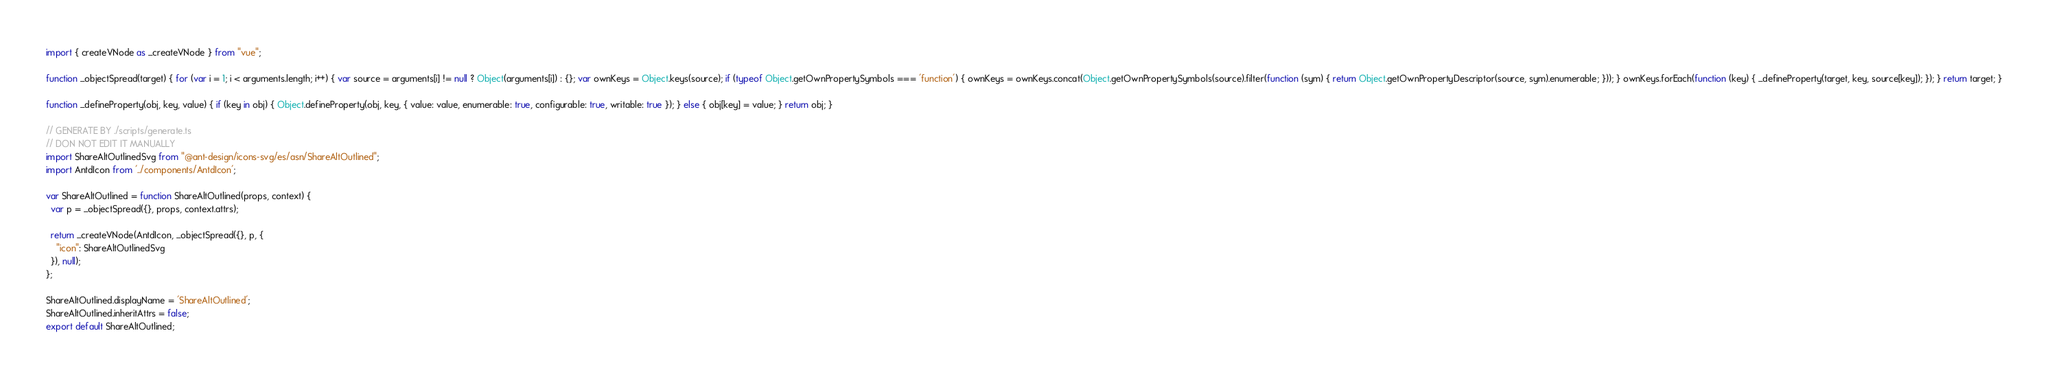Convert code to text. <code><loc_0><loc_0><loc_500><loc_500><_JavaScript_>import { createVNode as _createVNode } from "vue";

function _objectSpread(target) { for (var i = 1; i < arguments.length; i++) { var source = arguments[i] != null ? Object(arguments[i]) : {}; var ownKeys = Object.keys(source); if (typeof Object.getOwnPropertySymbols === 'function') { ownKeys = ownKeys.concat(Object.getOwnPropertySymbols(source).filter(function (sym) { return Object.getOwnPropertyDescriptor(source, sym).enumerable; })); } ownKeys.forEach(function (key) { _defineProperty(target, key, source[key]); }); } return target; }

function _defineProperty(obj, key, value) { if (key in obj) { Object.defineProperty(obj, key, { value: value, enumerable: true, configurable: true, writable: true }); } else { obj[key] = value; } return obj; }

// GENERATE BY ./scripts/generate.ts
// DON NOT EDIT IT MANUALLY
import ShareAltOutlinedSvg from "@ant-design/icons-svg/es/asn/ShareAltOutlined";
import AntdIcon from '../components/AntdIcon';

var ShareAltOutlined = function ShareAltOutlined(props, context) {
  var p = _objectSpread({}, props, context.attrs);

  return _createVNode(AntdIcon, _objectSpread({}, p, {
    "icon": ShareAltOutlinedSvg
  }), null);
};

ShareAltOutlined.displayName = 'ShareAltOutlined';
ShareAltOutlined.inheritAttrs = false;
export default ShareAltOutlined;</code> 